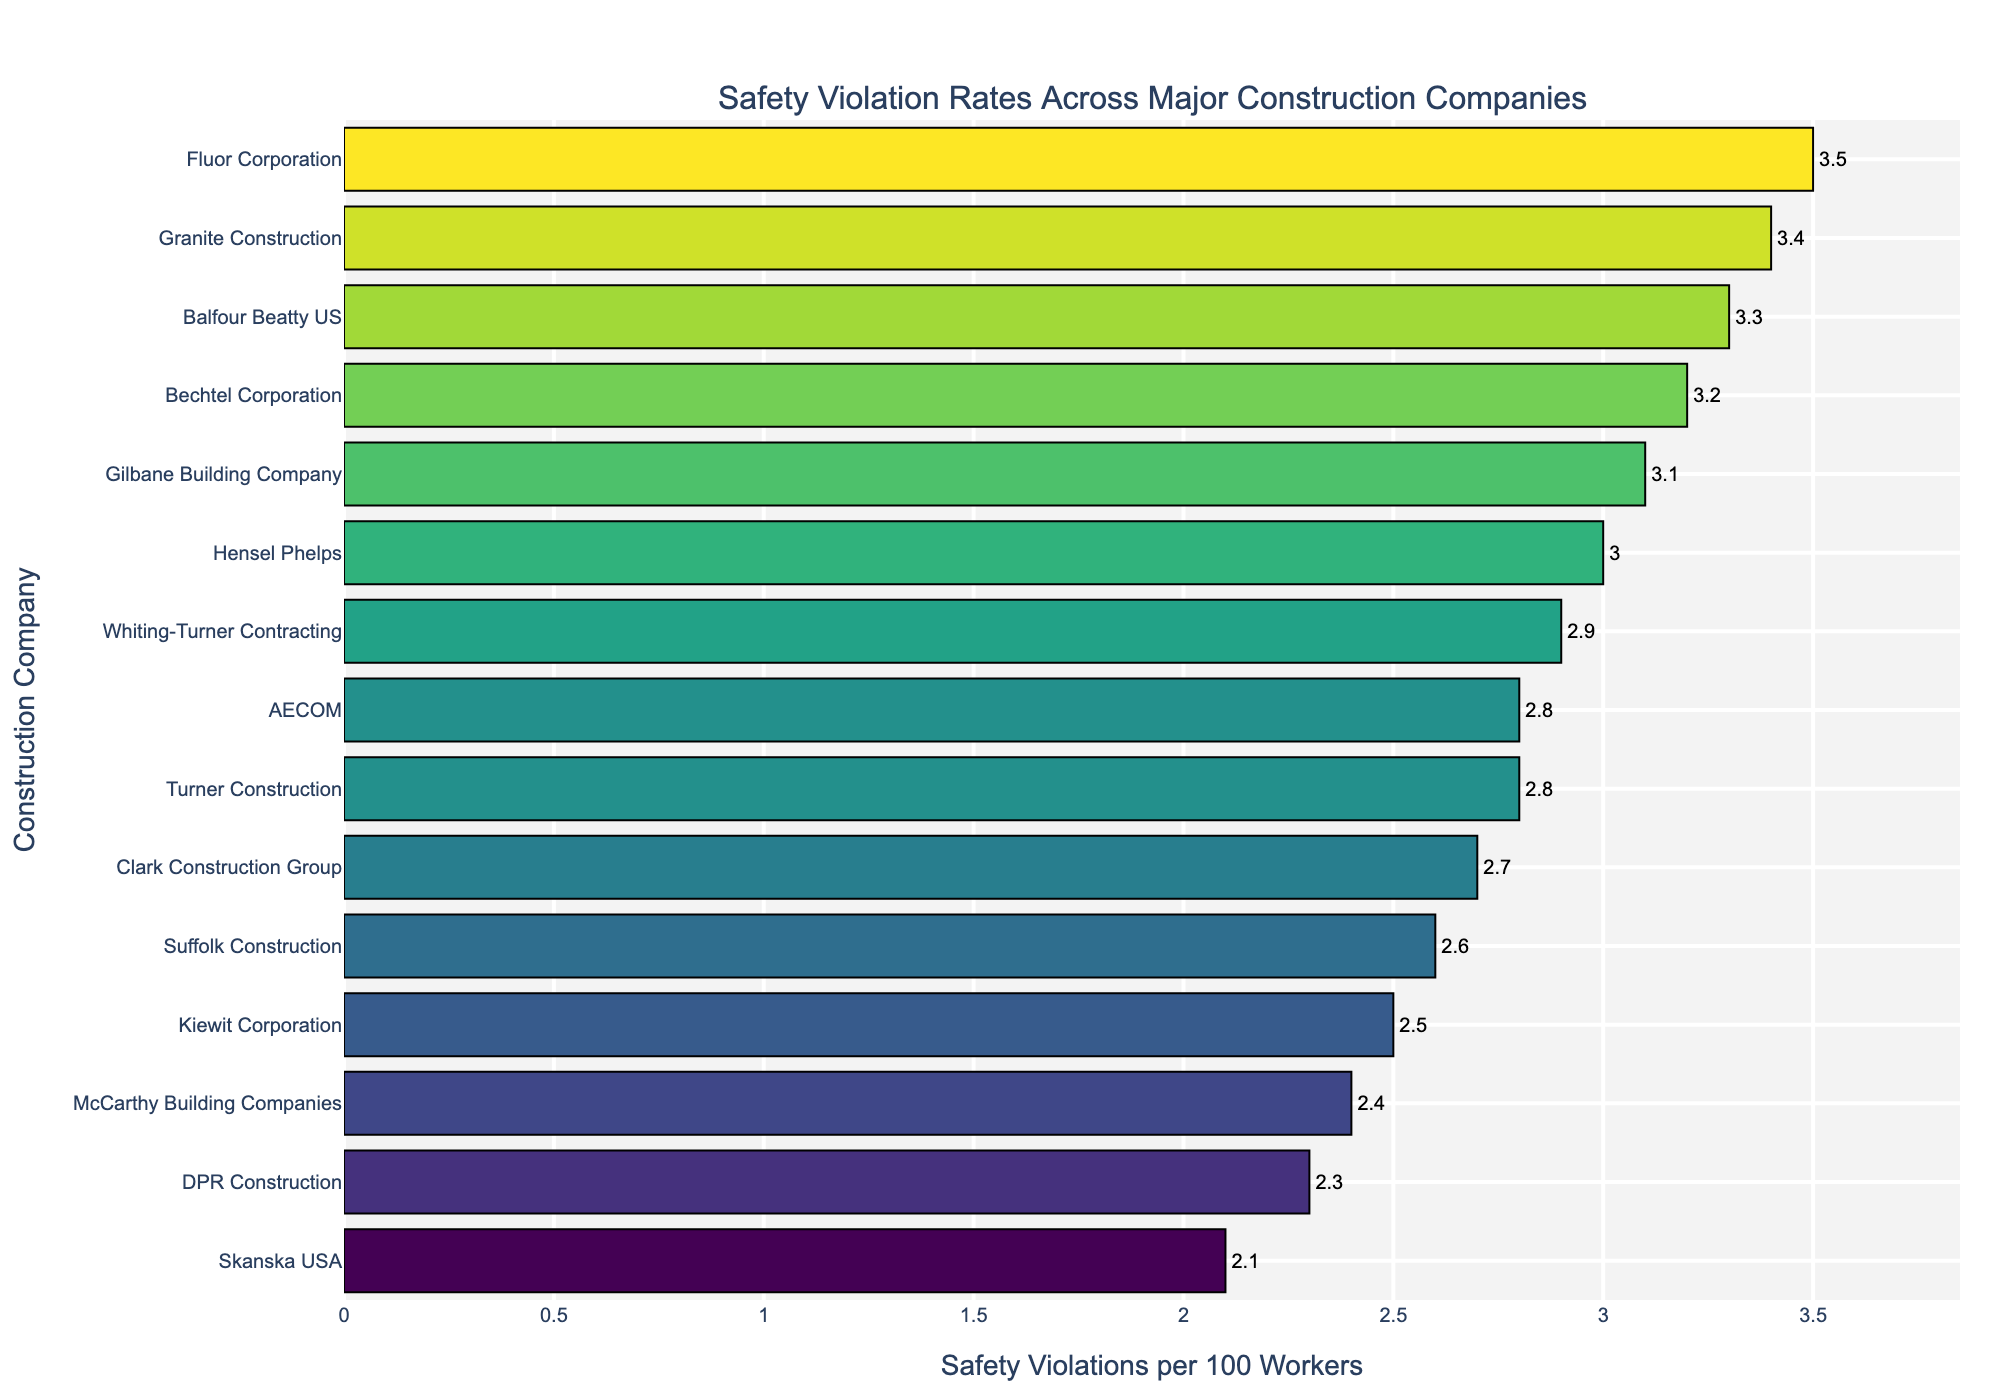Which company has the highest rate of safety violations? Look at the bar chart and identify the company name with the longest horizontal bar. This represents the highest value.
Answer: Fluor Corporation Which company has the lowest rate of safety violations? Identify the company name with the shortest horizontal bar in the bar chart, indicating the lowest value.
Answer: Skanska USA What is the difference in safety violation rates between Bechtel Corporation and Kiewit Corporation? Find the bar representing Bechtel Corporation and note its value (3.2). Then, find Kiewit Corporation's value (2.5). Subtract Kiewit's rate from Bechtel's rate: 3.2 - 2.5.
Answer: 0.7 Which company has a higher rate of safety violations, AECOM or Clark Construction Group? Compare the lengths of the bars representing AECOM and Clark Construction Group. Longer bars indicate higher values.
Answer: AECOM What is the combined safety violation rate for Whiting-Turner Contracting and McCarthy Building Companies? Identify the values for Whiting-Turner Contracting (2.9) and McCarthy Building Companies (2.4). Sum these values: 2.9 + 2.4.
Answer: 5.3 What is the average safety violation rate among all the companies listed? Sum the safety violation rates of all companies and divide by the number of companies. The sum is 41.3 (3.2 + 2.8 + 3.5 + 2.5 + 2.1 + 2.9 + 2.3 + 3.1 + 2.7 + 3.0 + 2.6 + 2.4 + 3.3 + 2.8 + 3.4). There are 15 companies, so the average is 41.3 / 15.
Answer: 2.75 Between Granite Construction and Balfour Beatty US, which company has a greater violation rate and by how much? Compare the bar lengths of Granite Construction (3.4) and Balfour Beatty US (3.3). Subtract Balfour Beatty US's rate from Granite Construction's rate: 3.4 - 3.3.
Answer: Granite Construction by 0.1 What is the median safety violation rate of the companies? Order the safety violation rates: [2.1, 2.3, 2.4, 2.5, 2.6, 2.7, 2.8, 2.8, 2.9, 3.0, 3.1, 3.2, 3.3, 3.4, 3.5], and find the middle value (8th value).
Answer: 2.8 Which companies have a safety violation rate above the median rate of 2.8? Identify the companies whose bars extend past the 2.8 mark. These are: Bechtel Corporation, Fluor Corporation, Gilbane Building Company, Hensel Phelps, Balfour Beatty US, and Granite Construction.
Answer: Bechtel Corporation, Fluor Corporation, Gilbane Building Company, Hensel Phelps, Balfour Beatty US, Granite Construction How does the safety violation rate of Suffolk Construction compare to the average rate of 2.75? Locate the bar for Suffolk Construction (2.6) and compare it to the average rate (2.75). Determine if it is higher, lower, or equal.
Answer: Lower 